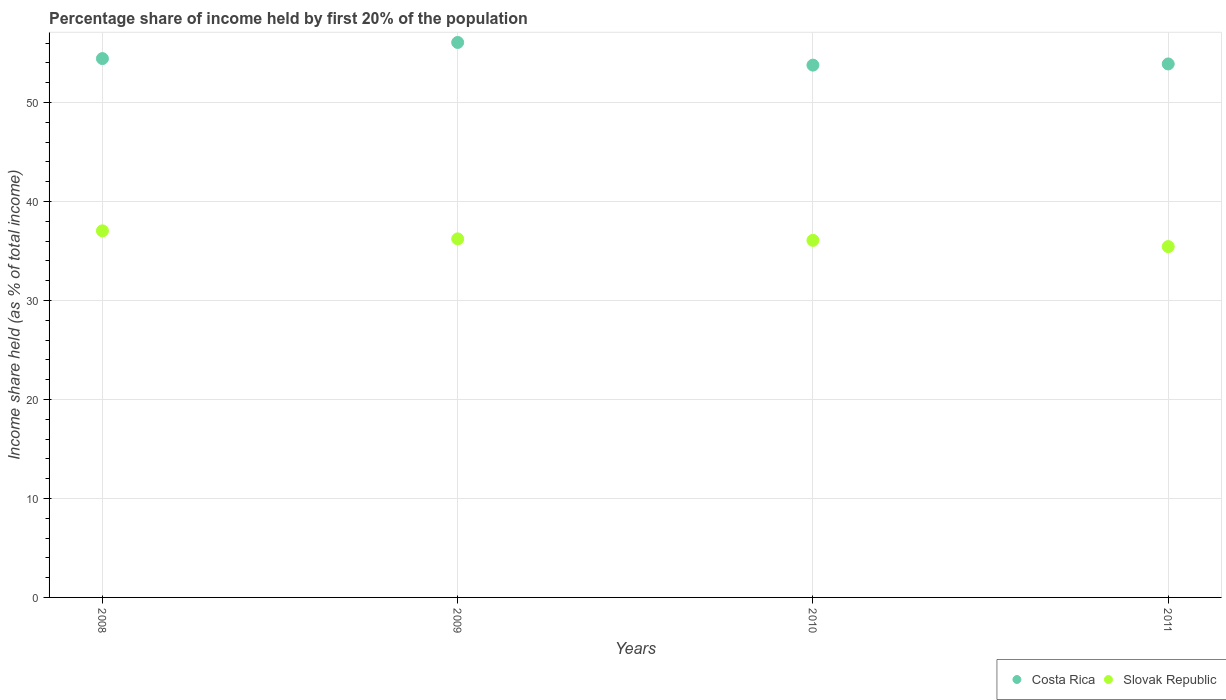What is the share of income held by first 20% of the population in Costa Rica in 2011?
Offer a terse response. 53.89. Across all years, what is the maximum share of income held by first 20% of the population in Slovak Republic?
Ensure brevity in your answer.  37.03. Across all years, what is the minimum share of income held by first 20% of the population in Slovak Republic?
Offer a very short reply. 35.44. In which year was the share of income held by first 20% of the population in Costa Rica minimum?
Offer a very short reply. 2010. What is the total share of income held by first 20% of the population in Slovak Republic in the graph?
Ensure brevity in your answer.  144.76. What is the difference between the share of income held by first 20% of the population in Slovak Republic in 2009 and that in 2011?
Give a very brief answer. 0.78. What is the difference between the share of income held by first 20% of the population in Slovak Republic in 2011 and the share of income held by first 20% of the population in Costa Rica in 2008?
Offer a very short reply. -18.99. What is the average share of income held by first 20% of the population in Slovak Republic per year?
Provide a short and direct response. 36.19. In the year 2010, what is the difference between the share of income held by first 20% of the population in Costa Rica and share of income held by first 20% of the population in Slovak Republic?
Provide a short and direct response. 17.7. In how many years, is the share of income held by first 20% of the population in Slovak Republic greater than 44 %?
Keep it short and to the point. 0. What is the ratio of the share of income held by first 20% of the population in Costa Rica in 2009 to that in 2010?
Give a very brief answer. 1.04. Is the share of income held by first 20% of the population in Costa Rica in 2008 less than that in 2010?
Provide a succinct answer. No. What is the difference between the highest and the second highest share of income held by first 20% of the population in Slovak Republic?
Offer a terse response. 0.81. What is the difference between the highest and the lowest share of income held by first 20% of the population in Costa Rica?
Your answer should be compact. 2.29. In how many years, is the share of income held by first 20% of the population in Slovak Republic greater than the average share of income held by first 20% of the population in Slovak Republic taken over all years?
Ensure brevity in your answer.  2. Does the share of income held by first 20% of the population in Costa Rica monotonically increase over the years?
Your response must be concise. No. How many dotlines are there?
Provide a succinct answer. 2. How many years are there in the graph?
Provide a succinct answer. 4. What is the difference between two consecutive major ticks on the Y-axis?
Make the answer very short. 10. Does the graph contain any zero values?
Your answer should be very brief. No. Does the graph contain grids?
Provide a short and direct response. Yes. How many legend labels are there?
Keep it short and to the point. 2. How are the legend labels stacked?
Provide a short and direct response. Horizontal. What is the title of the graph?
Your answer should be compact. Percentage share of income held by first 20% of the population. Does "Azerbaijan" appear as one of the legend labels in the graph?
Your answer should be very brief. No. What is the label or title of the X-axis?
Keep it short and to the point. Years. What is the label or title of the Y-axis?
Your answer should be compact. Income share held (as % of total income). What is the Income share held (as % of total income) in Costa Rica in 2008?
Your answer should be very brief. 54.43. What is the Income share held (as % of total income) of Slovak Republic in 2008?
Keep it short and to the point. 37.03. What is the Income share held (as % of total income) of Costa Rica in 2009?
Keep it short and to the point. 56.06. What is the Income share held (as % of total income) of Slovak Republic in 2009?
Keep it short and to the point. 36.22. What is the Income share held (as % of total income) in Costa Rica in 2010?
Give a very brief answer. 53.77. What is the Income share held (as % of total income) of Slovak Republic in 2010?
Keep it short and to the point. 36.07. What is the Income share held (as % of total income) of Costa Rica in 2011?
Ensure brevity in your answer.  53.89. What is the Income share held (as % of total income) of Slovak Republic in 2011?
Your answer should be compact. 35.44. Across all years, what is the maximum Income share held (as % of total income) in Costa Rica?
Make the answer very short. 56.06. Across all years, what is the maximum Income share held (as % of total income) of Slovak Republic?
Provide a succinct answer. 37.03. Across all years, what is the minimum Income share held (as % of total income) in Costa Rica?
Give a very brief answer. 53.77. Across all years, what is the minimum Income share held (as % of total income) in Slovak Republic?
Your answer should be compact. 35.44. What is the total Income share held (as % of total income) in Costa Rica in the graph?
Offer a terse response. 218.15. What is the total Income share held (as % of total income) in Slovak Republic in the graph?
Ensure brevity in your answer.  144.76. What is the difference between the Income share held (as % of total income) of Costa Rica in 2008 and that in 2009?
Your answer should be compact. -1.63. What is the difference between the Income share held (as % of total income) of Slovak Republic in 2008 and that in 2009?
Your answer should be very brief. 0.81. What is the difference between the Income share held (as % of total income) of Costa Rica in 2008 and that in 2010?
Give a very brief answer. 0.66. What is the difference between the Income share held (as % of total income) of Costa Rica in 2008 and that in 2011?
Your answer should be compact. 0.54. What is the difference between the Income share held (as % of total income) of Slovak Republic in 2008 and that in 2011?
Offer a terse response. 1.59. What is the difference between the Income share held (as % of total income) in Costa Rica in 2009 and that in 2010?
Your answer should be very brief. 2.29. What is the difference between the Income share held (as % of total income) in Costa Rica in 2009 and that in 2011?
Offer a terse response. 2.17. What is the difference between the Income share held (as % of total income) in Slovak Republic in 2009 and that in 2011?
Your answer should be compact. 0.78. What is the difference between the Income share held (as % of total income) in Costa Rica in 2010 and that in 2011?
Make the answer very short. -0.12. What is the difference between the Income share held (as % of total income) of Slovak Republic in 2010 and that in 2011?
Provide a succinct answer. 0.63. What is the difference between the Income share held (as % of total income) of Costa Rica in 2008 and the Income share held (as % of total income) of Slovak Republic in 2009?
Keep it short and to the point. 18.21. What is the difference between the Income share held (as % of total income) in Costa Rica in 2008 and the Income share held (as % of total income) in Slovak Republic in 2010?
Make the answer very short. 18.36. What is the difference between the Income share held (as % of total income) of Costa Rica in 2008 and the Income share held (as % of total income) of Slovak Republic in 2011?
Keep it short and to the point. 18.99. What is the difference between the Income share held (as % of total income) of Costa Rica in 2009 and the Income share held (as % of total income) of Slovak Republic in 2010?
Your response must be concise. 19.99. What is the difference between the Income share held (as % of total income) of Costa Rica in 2009 and the Income share held (as % of total income) of Slovak Republic in 2011?
Make the answer very short. 20.62. What is the difference between the Income share held (as % of total income) in Costa Rica in 2010 and the Income share held (as % of total income) in Slovak Republic in 2011?
Make the answer very short. 18.33. What is the average Income share held (as % of total income) in Costa Rica per year?
Make the answer very short. 54.54. What is the average Income share held (as % of total income) in Slovak Republic per year?
Give a very brief answer. 36.19. In the year 2009, what is the difference between the Income share held (as % of total income) of Costa Rica and Income share held (as % of total income) of Slovak Republic?
Make the answer very short. 19.84. In the year 2010, what is the difference between the Income share held (as % of total income) in Costa Rica and Income share held (as % of total income) in Slovak Republic?
Your answer should be compact. 17.7. In the year 2011, what is the difference between the Income share held (as % of total income) of Costa Rica and Income share held (as % of total income) of Slovak Republic?
Offer a terse response. 18.45. What is the ratio of the Income share held (as % of total income) of Costa Rica in 2008 to that in 2009?
Your response must be concise. 0.97. What is the ratio of the Income share held (as % of total income) of Slovak Republic in 2008 to that in 2009?
Your response must be concise. 1.02. What is the ratio of the Income share held (as % of total income) in Costa Rica in 2008 to that in 2010?
Provide a short and direct response. 1.01. What is the ratio of the Income share held (as % of total income) in Slovak Republic in 2008 to that in 2010?
Provide a succinct answer. 1.03. What is the ratio of the Income share held (as % of total income) in Slovak Republic in 2008 to that in 2011?
Your answer should be compact. 1.04. What is the ratio of the Income share held (as % of total income) of Costa Rica in 2009 to that in 2010?
Make the answer very short. 1.04. What is the ratio of the Income share held (as % of total income) in Slovak Republic in 2009 to that in 2010?
Offer a terse response. 1. What is the ratio of the Income share held (as % of total income) in Costa Rica in 2009 to that in 2011?
Make the answer very short. 1.04. What is the ratio of the Income share held (as % of total income) of Costa Rica in 2010 to that in 2011?
Give a very brief answer. 1. What is the ratio of the Income share held (as % of total income) in Slovak Republic in 2010 to that in 2011?
Provide a succinct answer. 1.02. What is the difference between the highest and the second highest Income share held (as % of total income) in Costa Rica?
Make the answer very short. 1.63. What is the difference between the highest and the second highest Income share held (as % of total income) in Slovak Republic?
Offer a terse response. 0.81. What is the difference between the highest and the lowest Income share held (as % of total income) of Costa Rica?
Your response must be concise. 2.29. What is the difference between the highest and the lowest Income share held (as % of total income) of Slovak Republic?
Provide a short and direct response. 1.59. 